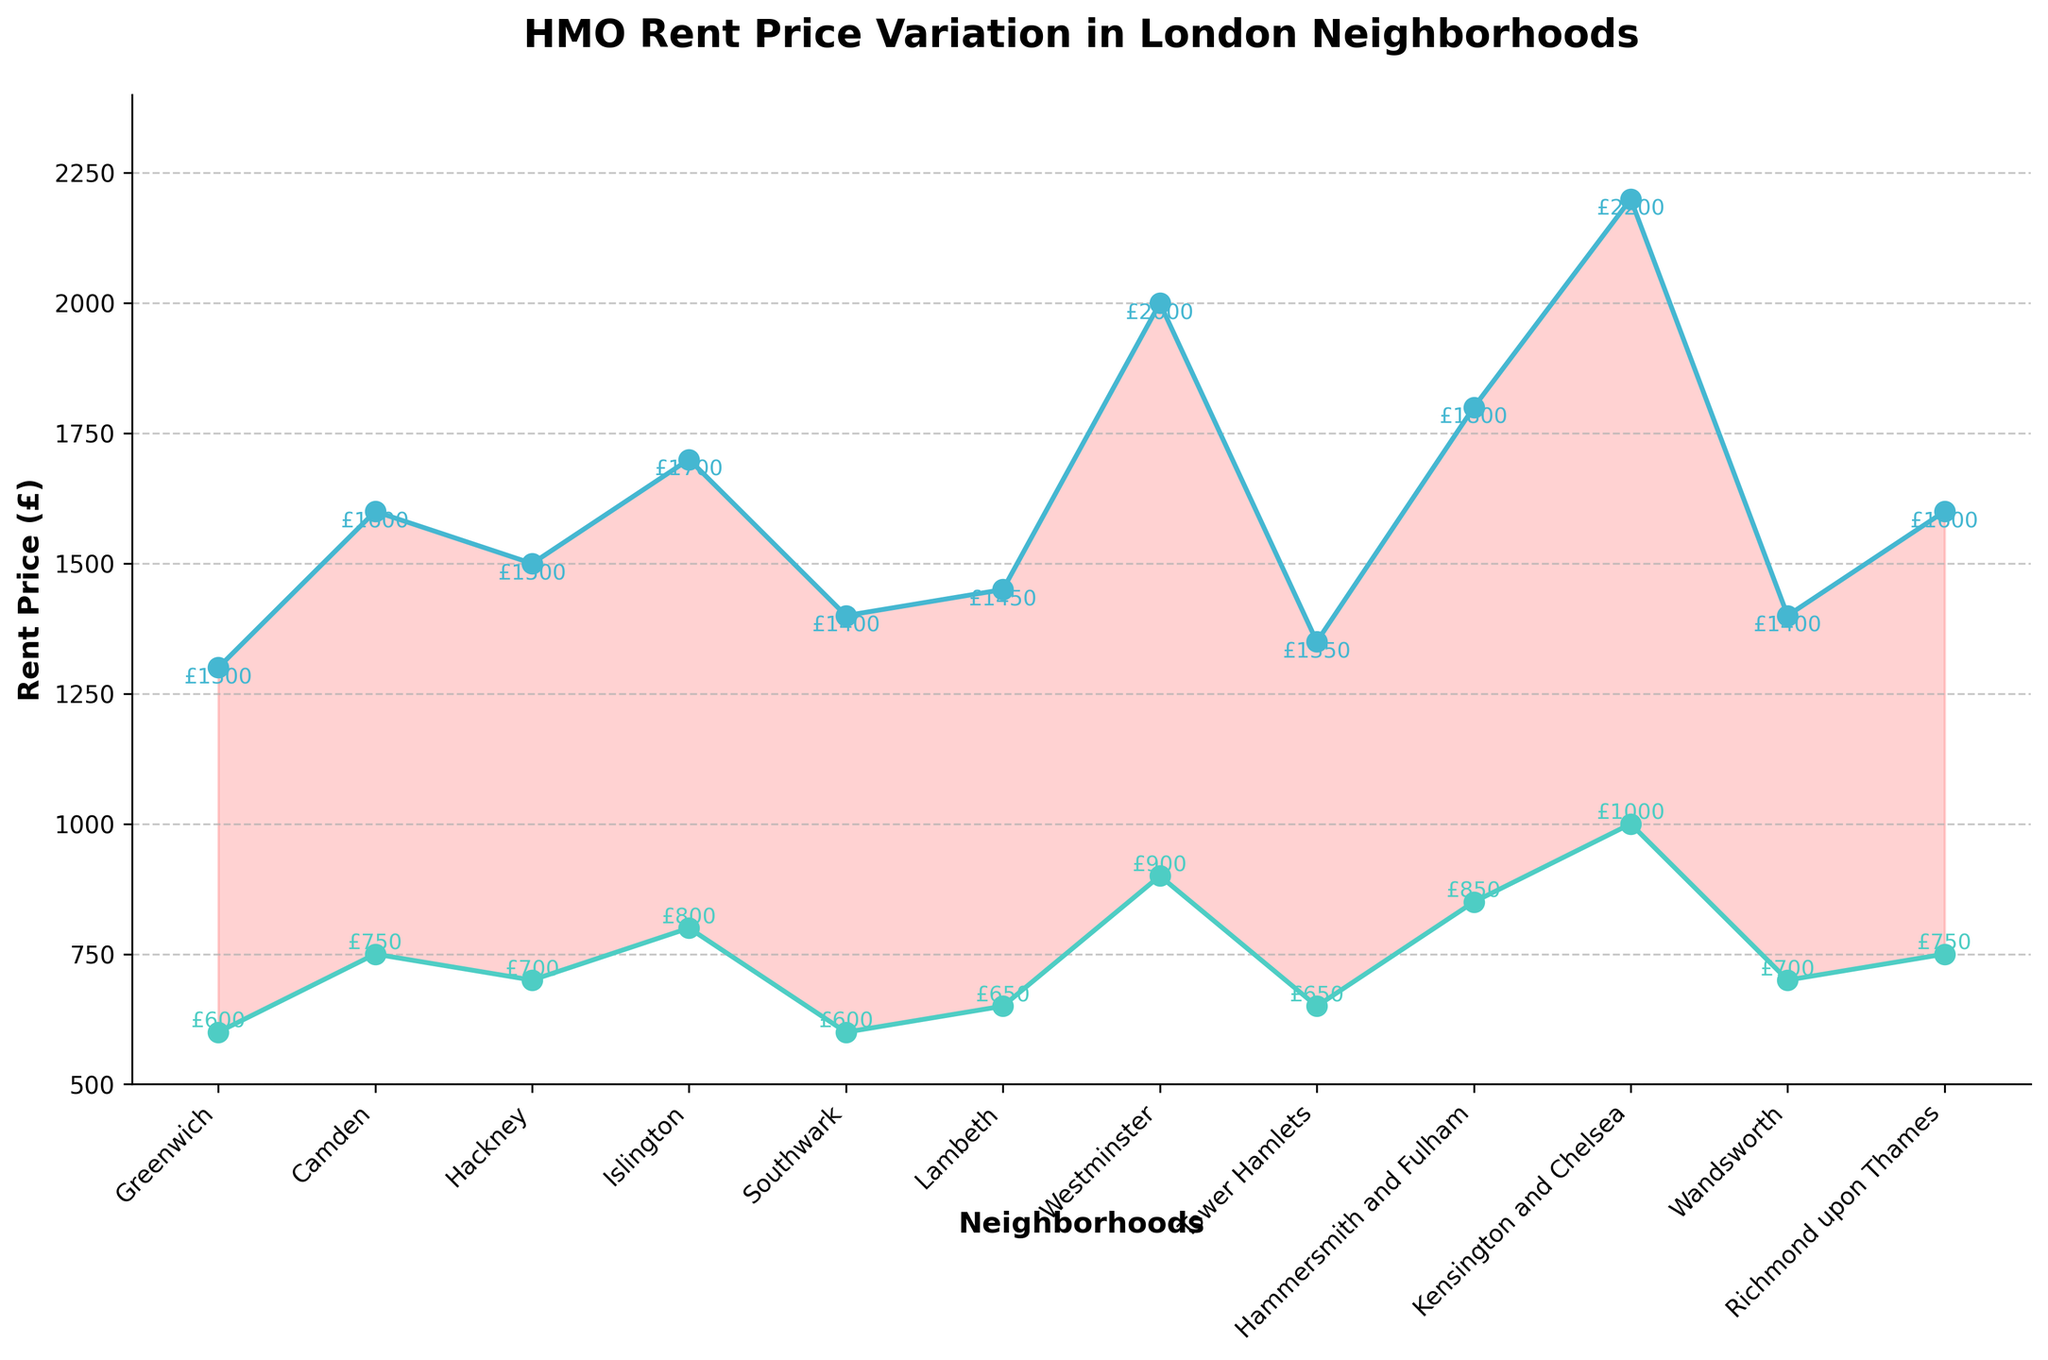Which neighborhood has the highest maximum rent? To determine the neighborhood with the highest maximum rent, look at the y-axis values for the highest points in the chart. Kensington and Chelsea has the highest point, indicating it has the highest maximum rent of £2200.
Answer: Kensington and Chelsea What is the minimum rent in Hackney? Identify the point on the lower line corresponding to Hackney and check the y-axis value. The minimum rent in Hackney is £700.
Answer: £700 Compare the minimum and maximum rents in Camden. What is the difference between them? Look at both the minimum and maximum rent line points for Camden and subtract the minimum rent from the maximum rent. For Camden: Maximum rent = £1600, Minimum rent = £750, Difference = £1600 - £750 = £850.
Answer: £850 Which neighborhood has the smallest range (difference) between its minimum and maximum rents? Calculate the rent difference for each neighborhood and check which is the smallest. Towers Hamlets has the smallest range, with a maximum of £1350 and a minimum of £650, giving a difference of £1350 - £650 = £700.
Answer: Tower Hamlets How do the rent ranges in Greenwich compare to those in Southwark? Calculate the difference between the maximum and minimum rents for both neighborhoods. Greenwich's range is £1300 - £600 = £700, and Southwark's range is £1400 - £600 = £800. Compare the two ranges to see that Southwark has a larger range by £100.
Answer: Southwark has a larger range by £100 What is the rent range for Islington? Find the difference between the maximum and minimum rent for Islington. Maximum rent = £1700, Minimum rent = £800. The range is £1700 - £800 = £900.
Answer: £900 Among all neighborhoods listed, which has both the lowest minimum rent and the highest maximum rent? Cross-check the minimum and maximum values to identify the lowest and highest respectively. Greenwich and Southwark have the lowest minimum rent of £600, and Kensington and Chelsea have the highest maximum rent of £2200.
Answer: Greenwich/Southwark for lowest minimum, Kensington and Chelsea for highest maximum Which neighborhood has a maximum rent closest to £1500? Examine the plotted maximum rent values and find the one closest to £1500. Hackney has a maximum rent of £1500, which is closest to the value in question.
Answer: Hackney If you wanted to live in a neighborhood with a minimum rent lower than £700, which neighborhoods would be options? Identify the neighborhoods whose minimum rent values are below £700. Greenwich and Southwark both have minimum rents of £600. Tower Hamlets also has a minimum rent of £650.
Answer: Greenwich, Southwark, Tower Hamlets What is the average of the maximum rents across all neighborhoods? Sum up all the maximum rents and divide by the number of neighborhoods. Sum of Maximum Rents = £1300 + £1600 + £1500 + £1700 + £1400 + £1450 + £2000 + £1350 + £1800 + £2200 + £1400 + £1600; Total = £19800; Number of Neighborhoods = 12; Average = £19800 / 12 = £1650.
Answer: £1650 